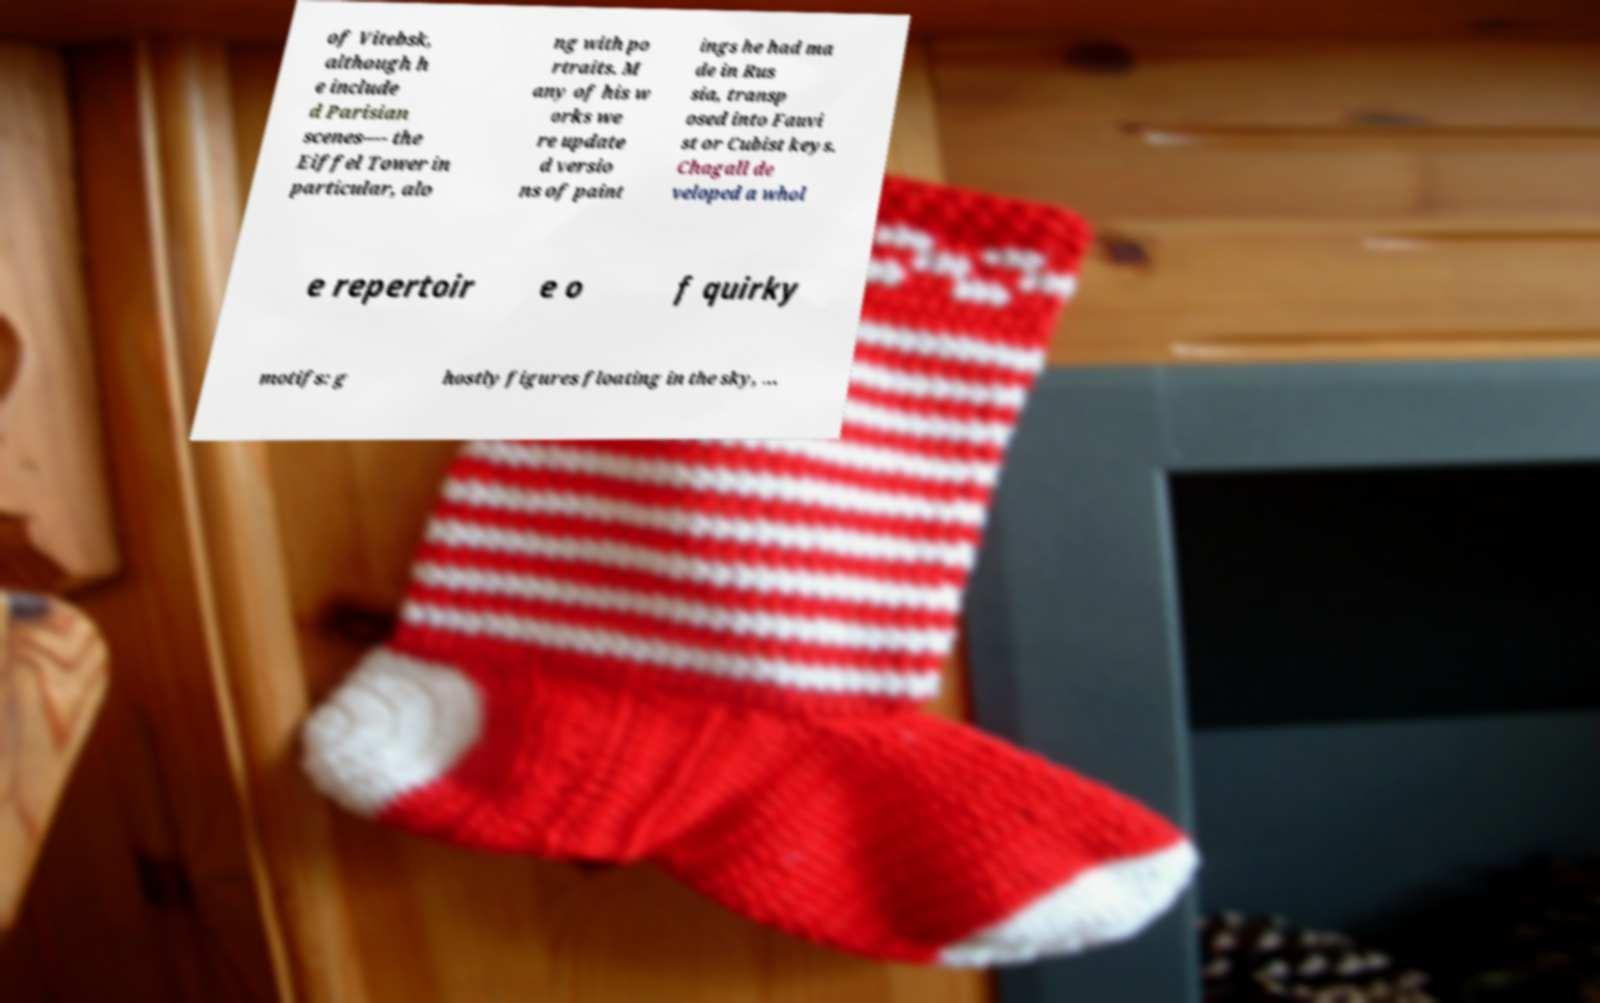What messages or text are displayed in this image? I need them in a readable, typed format. of Vitebsk, although h e include d Parisian scenes—- the Eiffel Tower in particular, alo ng with po rtraits. M any of his w orks we re update d versio ns of paint ings he had ma de in Rus sia, transp osed into Fauvi st or Cubist keys. Chagall de veloped a whol e repertoir e o f quirky motifs: g hostly figures floating in the sky, ... 